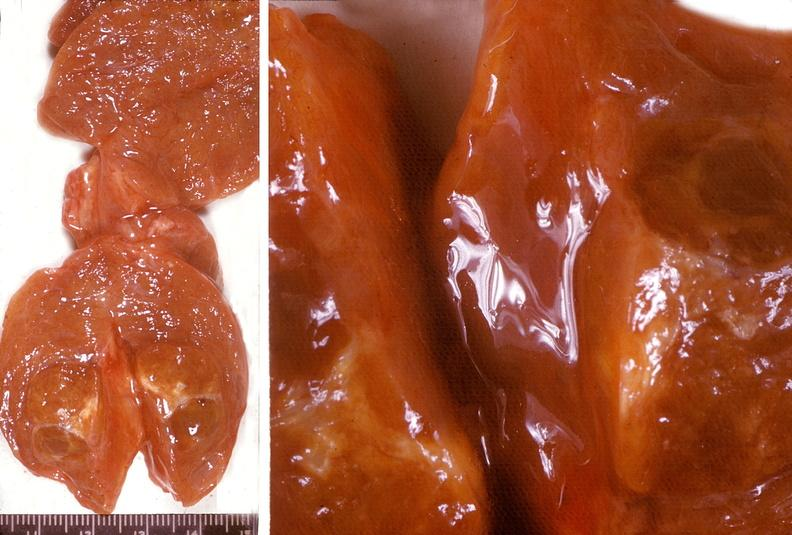where does this belong to?
Answer the question using a single word or phrase. Endocrine system 